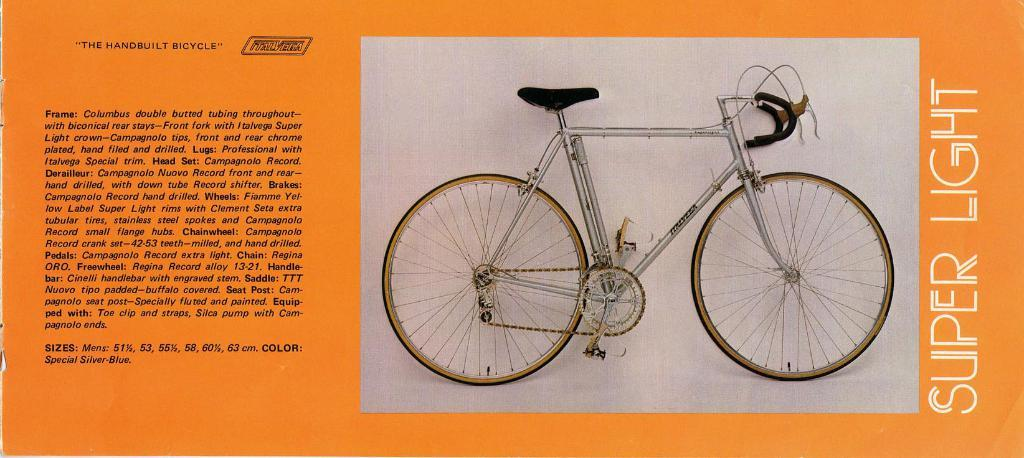What is the main subject of the image? The main subject of the image is a picture of a bicycle. What else is present in the image besides the picture of the bicycle? There is text beside the picture of the bicycle. What type of wine is being poured in the image? There is no wine present in the image; it features a picture of a bicycle and accompanying text. 